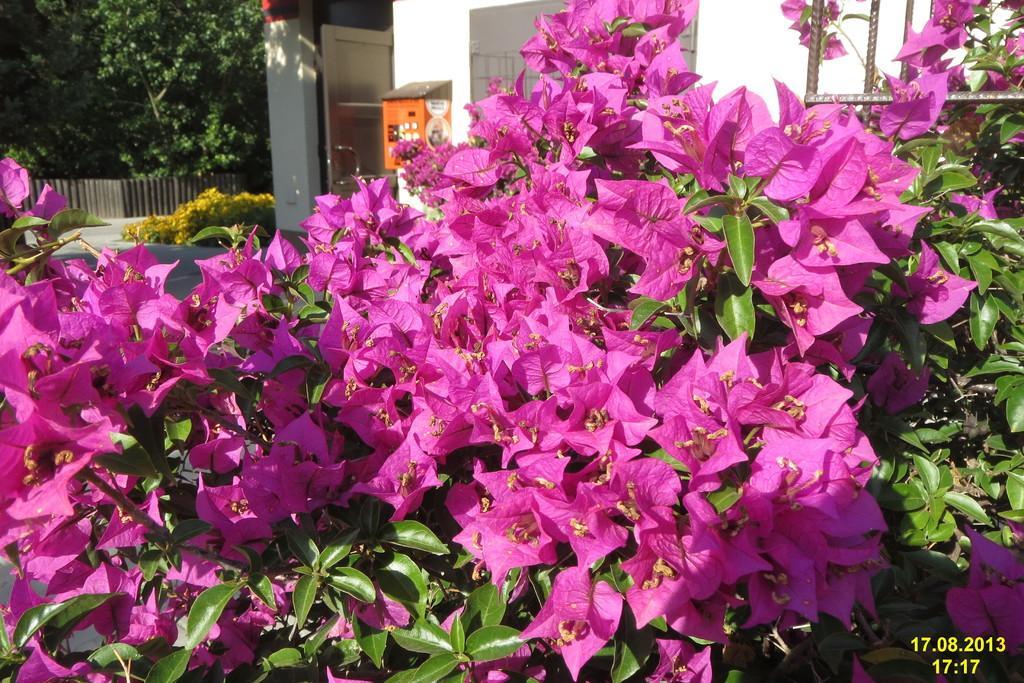Could you give a brief overview of what you see in this image? In this image, there is a plant contains some flowers. There is a building at the top of the image. There is a tree in the top left of the image. 